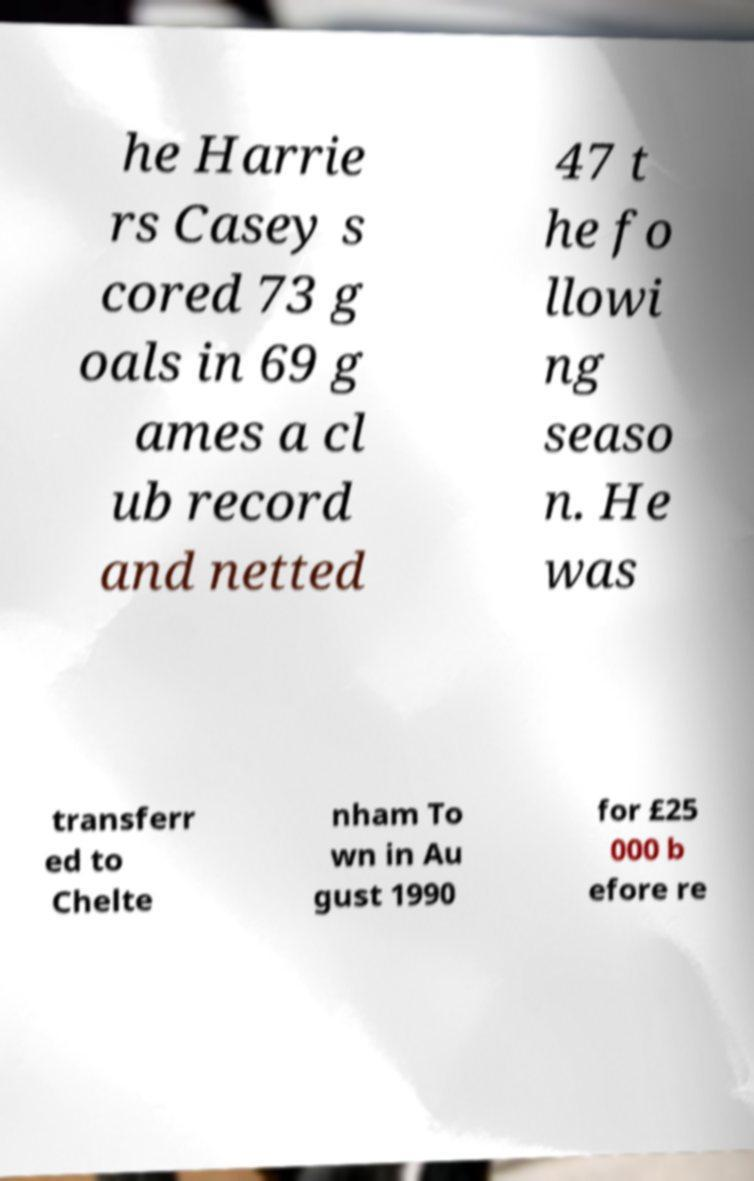Please identify and transcribe the text found in this image. he Harrie rs Casey s cored 73 g oals in 69 g ames a cl ub record and netted 47 t he fo llowi ng seaso n. He was transferr ed to Chelte nham To wn in Au gust 1990 for £25 000 b efore re 